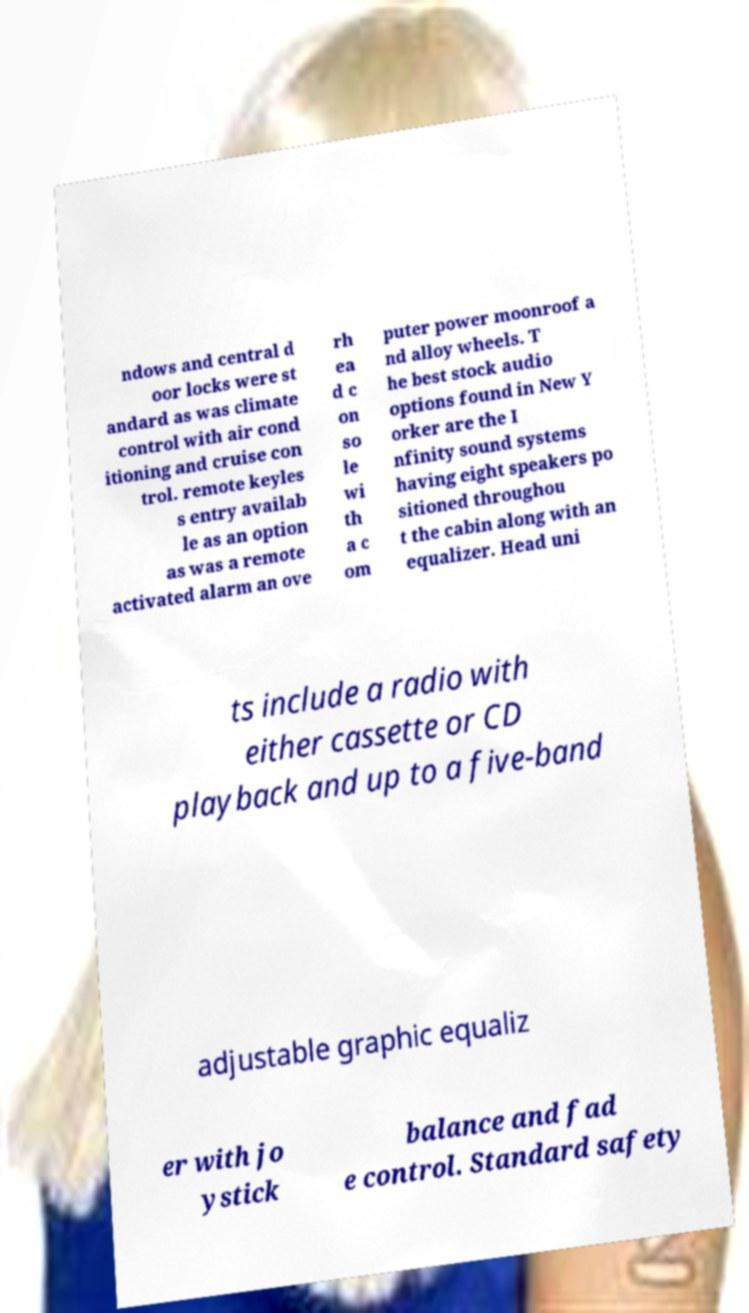For documentation purposes, I need the text within this image transcribed. Could you provide that? ndows and central d oor locks were st andard as was climate control with air cond itioning and cruise con trol. remote keyles s entry availab le as an option as was a remote activated alarm an ove rh ea d c on so le wi th a c om puter power moonroof a nd alloy wheels. T he best stock audio options found in New Y orker are the I nfinity sound systems having eight speakers po sitioned throughou t the cabin along with an equalizer. Head uni ts include a radio with either cassette or CD playback and up to a five-band adjustable graphic equaliz er with jo ystick balance and fad e control. Standard safety 